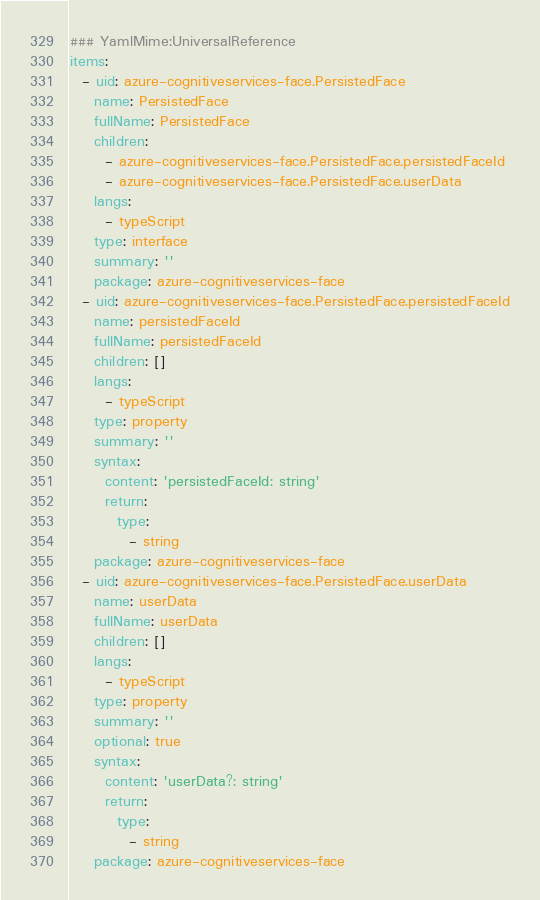Convert code to text. <code><loc_0><loc_0><loc_500><loc_500><_YAML_>### YamlMime:UniversalReference
items:
  - uid: azure-cognitiveservices-face.PersistedFace
    name: PersistedFace
    fullName: PersistedFace
    children:
      - azure-cognitiveservices-face.PersistedFace.persistedFaceId
      - azure-cognitiveservices-face.PersistedFace.userData
    langs:
      - typeScript
    type: interface
    summary: ''
    package: azure-cognitiveservices-face
  - uid: azure-cognitiveservices-face.PersistedFace.persistedFaceId
    name: persistedFaceId
    fullName: persistedFaceId
    children: []
    langs:
      - typeScript
    type: property
    summary: ''
    syntax:
      content: 'persistedFaceId: string'
      return:
        type:
          - string
    package: azure-cognitiveservices-face
  - uid: azure-cognitiveservices-face.PersistedFace.userData
    name: userData
    fullName: userData
    children: []
    langs:
      - typeScript
    type: property
    summary: ''
    optional: true
    syntax:
      content: 'userData?: string'
      return:
        type:
          - string
    package: azure-cognitiveservices-face
</code> 